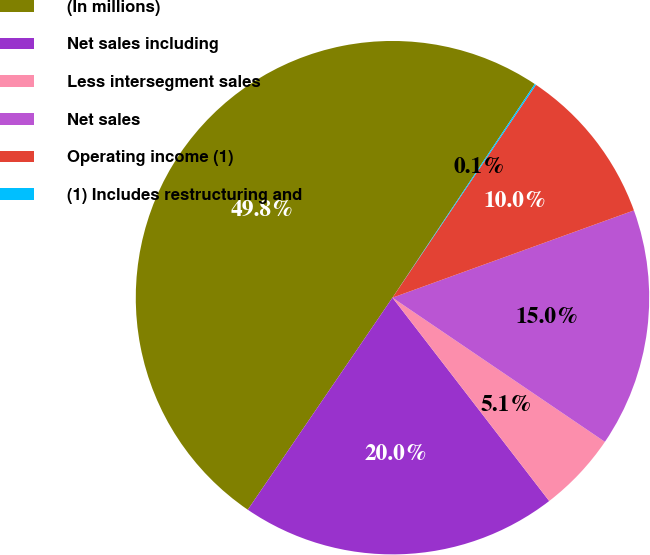Convert chart. <chart><loc_0><loc_0><loc_500><loc_500><pie_chart><fcel>(In millions)<fcel>Net sales including<fcel>Less intersegment sales<fcel>Net sales<fcel>Operating income (1)<fcel>(1) Includes restructuring and<nl><fcel>49.82%<fcel>19.98%<fcel>5.06%<fcel>15.01%<fcel>10.04%<fcel>0.09%<nl></chart> 